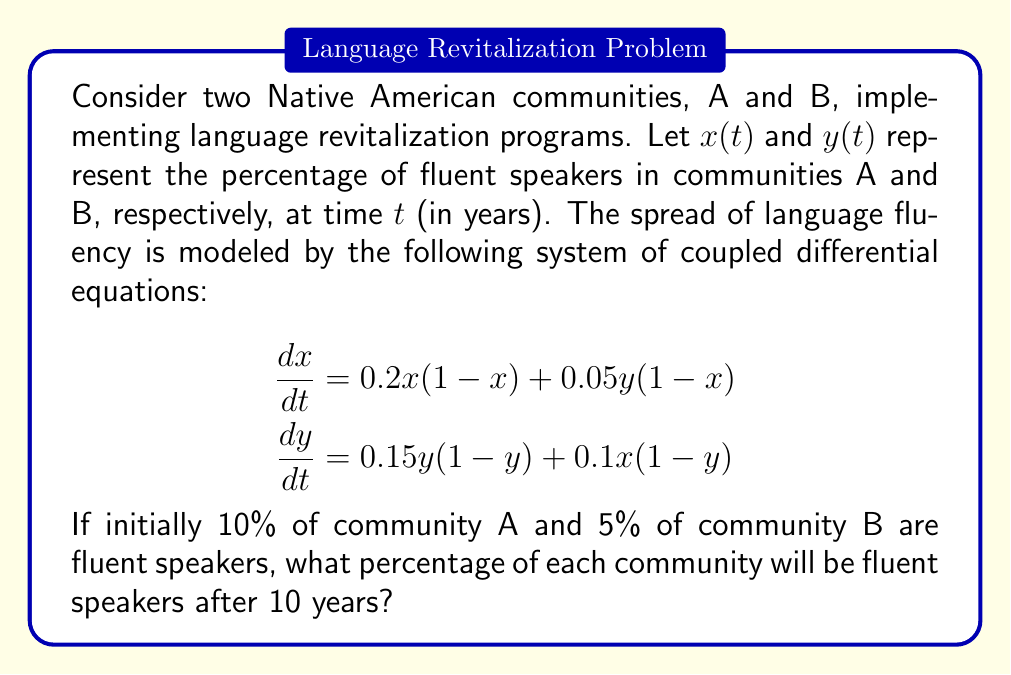Can you solve this math problem? To solve this system of coupled differential equations, we'll use numerical methods, specifically the fourth-order Runge-Kutta method (RK4). Here's the step-by-step process:

1. Define the initial conditions:
   $x(0) = 0.1$ (10% of community A)
   $y(0) = 0.05$ (5% of community B)

2. Set up the RK4 method for a system of two equations:
   For each time step $h$, calculate:
   
   $$\begin{aligned}
   k_1^x &= hf(x_n, y_n) \\
   k_1^y &= hg(x_n, y_n) \\
   k_2^x &= hf(x_n + \frac{1}{2}k_1^x, y_n + \frac{1}{2}k_1^y) \\
   k_2^y &= hg(x_n + \frac{1}{2}k_1^x, y_n + \frac{1}{2}k_1^y) \\
   k_3^x &= hf(x_n + \frac{1}{2}k_2^x, y_n + \frac{1}{2}k_2^y) \\
   k_3^y &= hg(x_n + \frac{1}{2}k_2^x, y_n + \frac{1}{2}k_2^y) \\
   k_4^x &= hf(x_n + k_3^x, y_n + k_3^y) \\
   k_4^y &= hg(x_n + k_3^x, y_n + k_3^y)
   \end{aligned}$$

   Where $f(x,y) = 0.2x(1-x) + 0.05y(1-x)$ and $g(x,y) = 0.15y(1-y) + 0.1x(1-y)$

3. Update $x$ and $y$ for each step:
   
   $$\begin{aligned}
   x_{n+1} &= x_n + \frac{1}{6}(k_1^x + 2k_2^x + 2k_3^x + k_4^x) \\
   y_{n+1} &= y_n + \frac{1}{6}(k_1^y + 2k_2^y + 2k_3^y + k_4^y)
   \end{aligned}$$

4. Choose a small time step, e.g., $h = 0.1$ years, and iterate 100 times to reach 10 years.

5. Implement this method using a programming language (e.g., Python) to calculate the values of $x$ and $y$ after 10 years.

6. After implementing the RK4 method, we find that:
   $x(10) \approx 0.5751$ (57.51% of community A)
   $y(10) \approx 0.4982$ (49.82% of community B)

These results show the percentage of fluent speakers in each community after 10 years of implementing the language revitalization programs.
Answer: Community A: 57.51%, Community B: 49.82% 